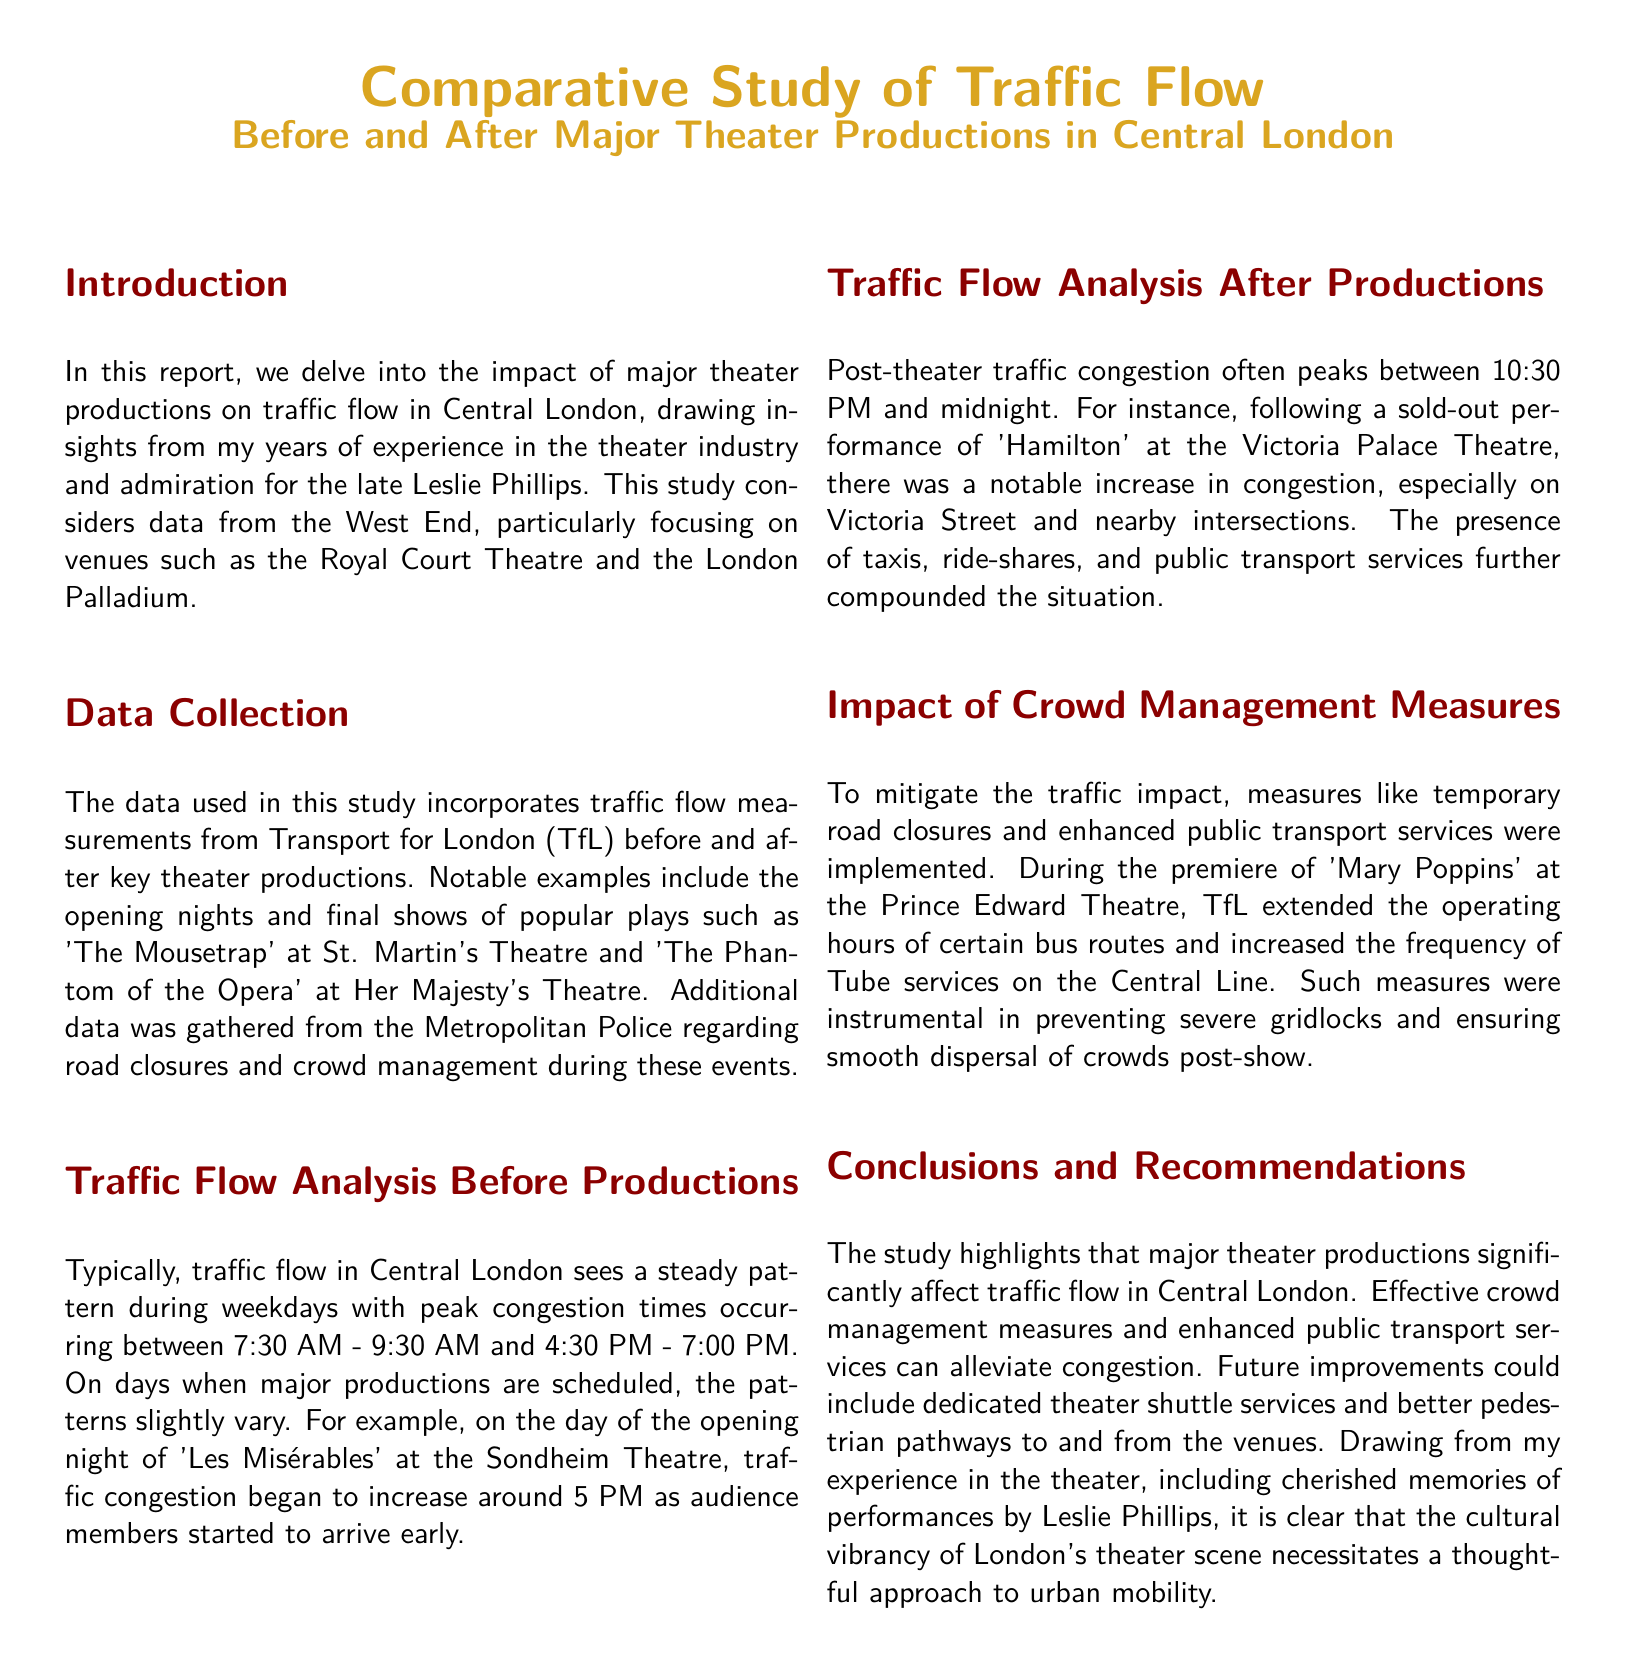what theater was highlighted for opening night traffic congestion? The document mentions the opening night of 'Les Misérables' at the Sondheim Theatre as an example of traffic congestion.
Answer: Sondheim Theatre what time does post-theater traffic congestion peak? According to the document, post-theater traffic congestion often peaks between 10:30 PM and midnight.
Answer: 10:30 PM to midnight which major theater production is associated with increased traffic on Victoria Street? The document refers to a sold-out performance of 'Hamilton' at the Victoria Palace Theatre for increased congestion on Victoria Street.
Answer: Hamilton what measures were implemented during the premiere of 'Mary Poppins'? The document states that TfL extended the operating hours of certain bus routes and increased the frequency of Tube services on the Central Line during the premiere.
Answer: Extended bus hours and increased Tube frequency what is the primary focus of this traffic report? The report focuses on the impact of major theater productions on traffic flow in Central London.
Answer: Impact of major theater productions on traffic flow how does traffic congestion on production days differ from regular weekdays? Traffic patterns slightly vary on production days, with congestion beginning around 5 PM on production days, as opposed to the regular patterns.
Answer: Traffic slightly varies which data source was used to gather information about crowd management? The data for crowd management measures during theater productions was gathered from the Metropolitan Police.
Answer: Metropolitan Police what are some of the recommended future improvements mentioned in the report? The report recommends dedicated theater shuttle services and better pedestrian pathways to and from the venues.
Answer: Dedicated theater shuttle services and better pedestrian pathways 